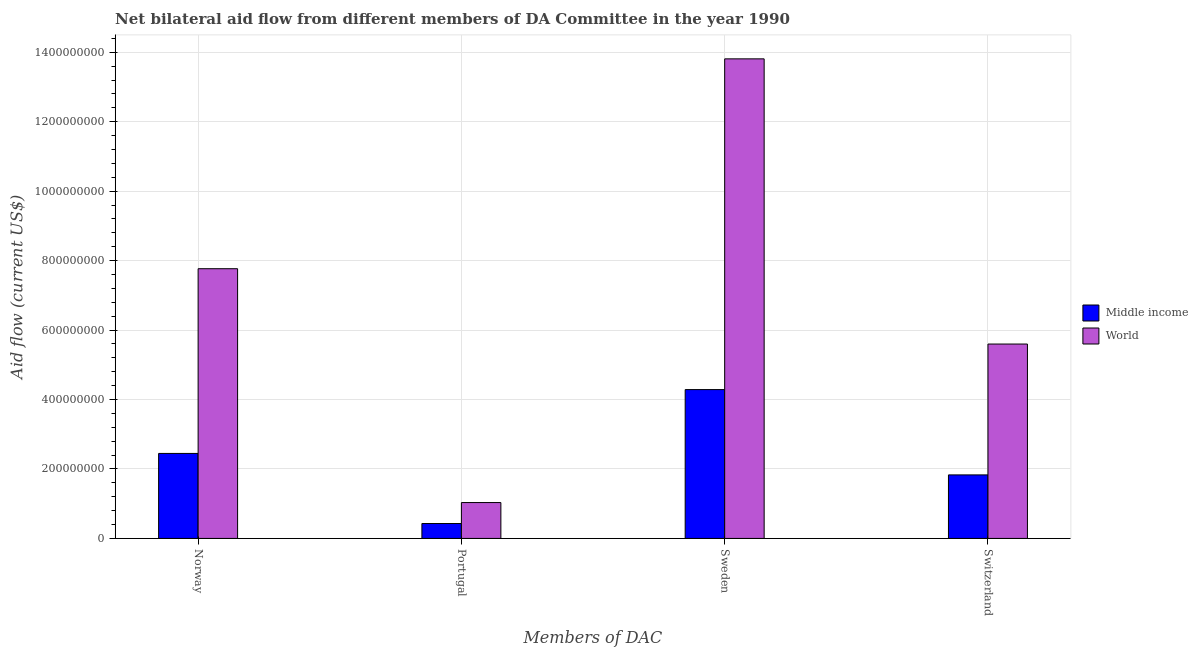How many different coloured bars are there?
Give a very brief answer. 2. How many groups of bars are there?
Provide a short and direct response. 4. Are the number of bars on each tick of the X-axis equal?
Ensure brevity in your answer.  Yes. How many bars are there on the 2nd tick from the right?
Provide a succinct answer. 2. What is the amount of aid given by switzerland in Middle income?
Offer a terse response. 1.83e+08. Across all countries, what is the maximum amount of aid given by sweden?
Keep it short and to the point. 1.38e+09. Across all countries, what is the minimum amount of aid given by sweden?
Provide a short and direct response. 4.29e+08. In which country was the amount of aid given by norway minimum?
Your answer should be compact. Middle income. What is the total amount of aid given by switzerland in the graph?
Provide a succinct answer. 7.43e+08. What is the difference between the amount of aid given by switzerland in Middle income and that in World?
Keep it short and to the point. -3.77e+08. What is the difference between the amount of aid given by sweden in World and the amount of aid given by switzerland in Middle income?
Offer a very short reply. 1.20e+09. What is the average amount of aid given by norway per country?
Your response must be concise. 5.11e+08. What is the difference between the amount of aid given by norway and amount of aid given by switzerland in World?
Make the answer very short. 2.17e+08. In how many countries, is the amount of aid given by sweden greater than 640000000 US$?
Provide a succinct answer. 1. What is the ratio of the amount of aid given by sweden in Middle income to that in World?
Provide a succinct answer. 0.31. What is the difference between the highest and the second highest amount of aid given by norway?
Your answer should be very brief. 5.32e+08. What is the difference between the highest and the lowest amount of aid given by norway?
Your response must be concise. 5.32e+08. In how many countries, is the amount of aid given by sweden greater than the average amount of aid given by sweden taken over all countries?
Your answer should be very brief. 1. Is it the case that in every country, the sum of the amount of aid given by sweden and amount of aid given by switzerland is greater than the sum of amount of aid given by norway and amount of aid given by portugal?
Offer a very short reply. No. What does the 1st bar from the right in Switzerland represents?
Your response must be concise. World. How many countries are there in the graph?
Ensure brevity in your answer.  2. What is the difference between two consecutive major ticks on the Y-axis?
Your answer should be compact. 2.00e+08. Does the graph contain any zero values?
Make the answer very short. No. Does the graph contain grids?
Your response must be concise. Yes. Where does the legend appear in the graph?
Offer a very short reply. Center right. How many legend labels are there?
Provide a succinct answer. 2. How are the legend labels stacked?
Provide a succinct answer. Vertical. What is the title of the graph?
Your response must be concise. Net bilateral aid flow from different members of DA Committee in the year 1990. Does "Pacific island small states" appear as one of the legend labels in the graph?
Ensure brevity in your answer.  No. What is the label or title of the X-axis?
Provide a succinct answer. Members of DAC. What is the Aid flow (current US$) of Middle income in Norway?
Offer a terse response. 2.45e+08. What is the Aid flow (current US$) of World in Norway?
Provide a succinct answer. 7.77e+08. What is the Aid flow (current US$) in Middle income in Portugal?
Offer a terse response. 4.29e+07. What is the Aid flow (current US$) in World in Portugal?
Your answer should be compact. 1.03e+08. What is the Aid flow (current US$) in Middle income in Sweden?
Keep it short and to the point. 4.29e+08. What is the Aid flow (current US$) in World in Sweden?
Offer a terse response. 1.38e+09. What is the Aid flow (current US$) in Middle income in Switzerland?
Offer a very short reply. 1.83e+08. What is the Aid flow (current US$) of World in Switzerland?
Your answer should be very brief. 5.60e+08. Across all Members of DAC, what is the maximum Aid flow (current US$) of Middle income?
Your answer should be very brief. 4.29e+08. Across all Members of DAC, what is the maximum Aid flow (current US$) of World?
Keep it short and to the point. 1.38e+09. Across all Members of DAC, what is the minimum Aid flow (current US$) in Middle income?
Keep it short and to the point. 4.29e+07. Across all Members of DAC, what is the minimum Aid flow (current US$) in World?
Offer a terse response. 1.03e+08. What is the total Aid flow (current US$) in Middle income in the graph?
Keep it short and to the point. 8.99e+08. What is the total Aid flow (current US$) of World in the graph?
Your answer should be very brief. 2.82e+09. What is the difference between the Aid flow (current US$) in Middle income in Norway and that in Portugal?
Give a very brief answer. 2.02e+08. What is the difference between the Aid flow (current US$) in World in Norway and that in Portugal?
Your answer should be very brief. 6.73e+08. What is the difference between the Aid flow (current US$) of Middle income in Norway and that in Sweden?
Your answer should be compact. -1.84e+08. What is the difference between the Aid flow (current US$) of World in Norway and that in Sweden?
Provide a short and direct response. -6.04e+08. What is the difference between the Aid flow (current US$) of Middle income in Norway and that in Switzerland?
Provide a short and direct response. 6.18e+07. What is the difference between the Aid flow (current US$) of World in Norway and that in Switzerland?
Your answer should be very brief. 2.17e+08. What is the difference between the Aid flow (current US$) of Middle income in Portugal and that in Sweden?
Make the answer very short. -3.86e+08. What is the difference between the Aid flow (current US$) in World in Portugal and that in Sweden?
Your answer should be very brief. -1.28e+09. What is the difference between the Aid flow (current US$) of Middle income in Portugal and that in Switzerland?
Provide a short and direct response. -1.40e+08. What is the difference between the Aid flow (current US$) of World in Portugal and that in Switzerland?
Your answer should be compact. -4.56e+08. What is the difference between the Aid flow (current US$) in Middle income in Sweden and that in Switzerland?
Give a very brief answer. 2.46e+08. What is the difference between the Aid flow (current US$) in World in Sweden and that in Switzerland?
Give a very brief answer. 8.21e+08. What is the difference between the Aid flow (current US$) of Middle income in Norway and the Aid flow (current US$) of World in Portugal?
Provide a succinct answer. 1.41e+08. What is the difference between the Aid flow (current US$) of Middle income in Norway and the Aid flow (current US$) of World in Sweden?
Ensure brevity in your answer.  -1.14e+09. What is the difference between the Aid flow (current US$) of Middle income in Norway and the Aid flow (current US$) of World in Switzerland?
Your answer should be compact. -3.15e+08. What is the difference between the Aid flow (current US$) in Middle income in Portugal and the Aid flow (current US$) in World in Sweden?
Your answer should be very brief. -1.34e+09. What is the difference between the Aid flow (current US$) in Middle income in Portugal and the Aid flow (current US$) in World in Switzerland?
Your response must be concise. -5.17e+08. What is the difference between the Aid flow (current US$) of Middle income in Sweden and the Aid flow (current US$) of World in Switzerland?
Give a very brief answer. -1.31e+08. What is the average Aid flow (current US$) of Middle income per Members of DAC?
Ensure brevity in your answer.  2.25e+08. What is the average Aid flow (current US$) in World per Members of DAC?
Make the answer very short. 7.05e+08. What is the difference between the Aid flow (current US$) of Middle income and Aid flow (current US$) of World in Norway?
Your response must be concise. -5.32e+08. What is the difference between the Aid flow (current US$) of Middle income and Aid flow (current US$) of World in Portugal?
Provide a short and direct response. -6.04e+07. What is the difference between the Aid flow (current US$) in Middle income and Aid flow (current US$) in World in Sweden?
Offer a terse response. -9.52e+08. What is the difference between the Aid flow (current US$) in Middle income and Aid flow (current US$) in World in Switzerland?
Give a very brief answer. -3.77e+08. What is the ratio of the Aid flow (current US$) of Middle income in Norway to that in Portugal?
Provide a short and direct response. 5.7. What is the ratio of the Aid flow (current US$) in World in Norway to that in Portugal?
Your response must be concise. 7.52. What is the ratio of the Aid flow (current US$) of Middle income in Norway to that in Sweden?
Your answer should be very brief. 0.57. What is the ratio of the Aid flow (current US$) of World in Norway to that in Sweden?
Provide a succinct answer. 0.56. What is the ratio of the Aid flow (current US$) in Middle income in Norway to that in Switzerland?
Your response must be concise. 1.34. What is the ratio of the Aid flow (current US$) of World in Norway to that in Switzerland?
Give a very brief answer. 1.39. What is the ratio of the Aid flow (current US$) in Middle income in Portugal to that in Sweden?
Provide a succinct answer. 0.1. What is the ratio of the Aid flow (current US$) of World in Portugal to that in Sweden?
Your answer should be very brief. 0.07. What is the ratio of the Aid flow (current US$) of Middle income in Portugal to that in Switzerland?
Offer a very short reply. 0.23. What is the ratio of the Aid flow (current US$) in World in Portugal to that in Switzerland?
Your answer should be very brief. 0.18. What is the ratio of the Aid flow (current US$) in Middle income in Sweden to that in Switzerland?
Provide a short and direct response. 2.34. What is the ratio of the Aid flow (current US$) of World in Sweden to that in Switzerland?
Provide a succinct answer. 2.47. What is the difference between the highest and the second highest Aid flow (current US$) of Middle income?
Your answer should be very brief. 1.84e+08. What is the difference between the highest and the second highest Aid flow (current US$) of World?
Provide a succinct answer. 6.04e+08. What is the difference between the highest and the lowest Aid flow (current US$) in Middle income?
Your response must be concise. 3.86e+08. What is the difference between the highest and the lowest Aid flow (current US$) of World?
Your answer should be very brief. 1.28e+09. 